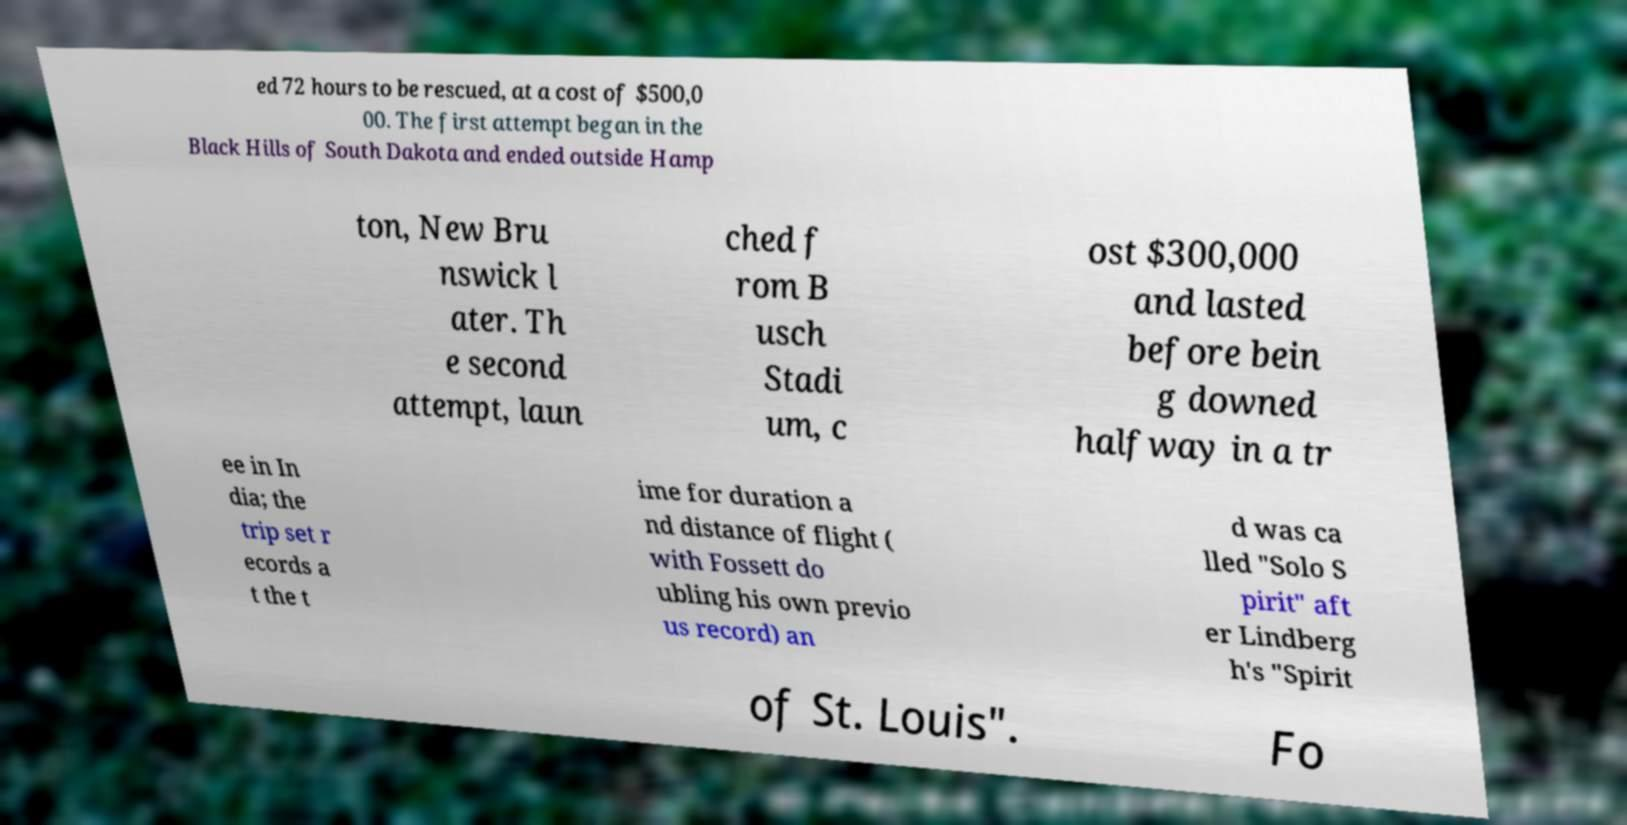Please read and relay the text visible in this image. What does it say? ed 72 hours to be rescued, at a cost of $500,0 00. The first attempt began in the Black Hills of South Dakota and ended outside Hamp ton, New Bru nswick l ater. Th e second attempt, laun ched f rom B usch Stadi um, c ost $300,000 and lasted before bein g downed halfway in a tr ee in In dia; the trip set r ecords a t the t ime for duration a nd distance of flight ( with Fossett do ubling his own previo us record) an d was ca lled "Solo S pirit" aft er Lindberg h's "Spirit of St. Louis". Fo 